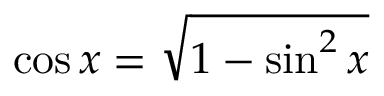Convert formula to latex. <formula><loc_0><loc_0><loc_500><loc_500>\cos x = { \sqrt { 1 - \sin ^ { 2 } x } }</formula> 